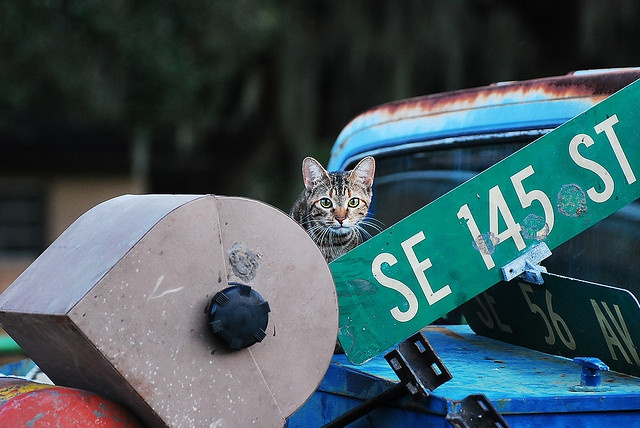Describe the objects in this image and their specific colors. I can see truck in black, lightblue, and darkblue tones and cat in black, darkgray, gray, and lightgray tones in this image. 